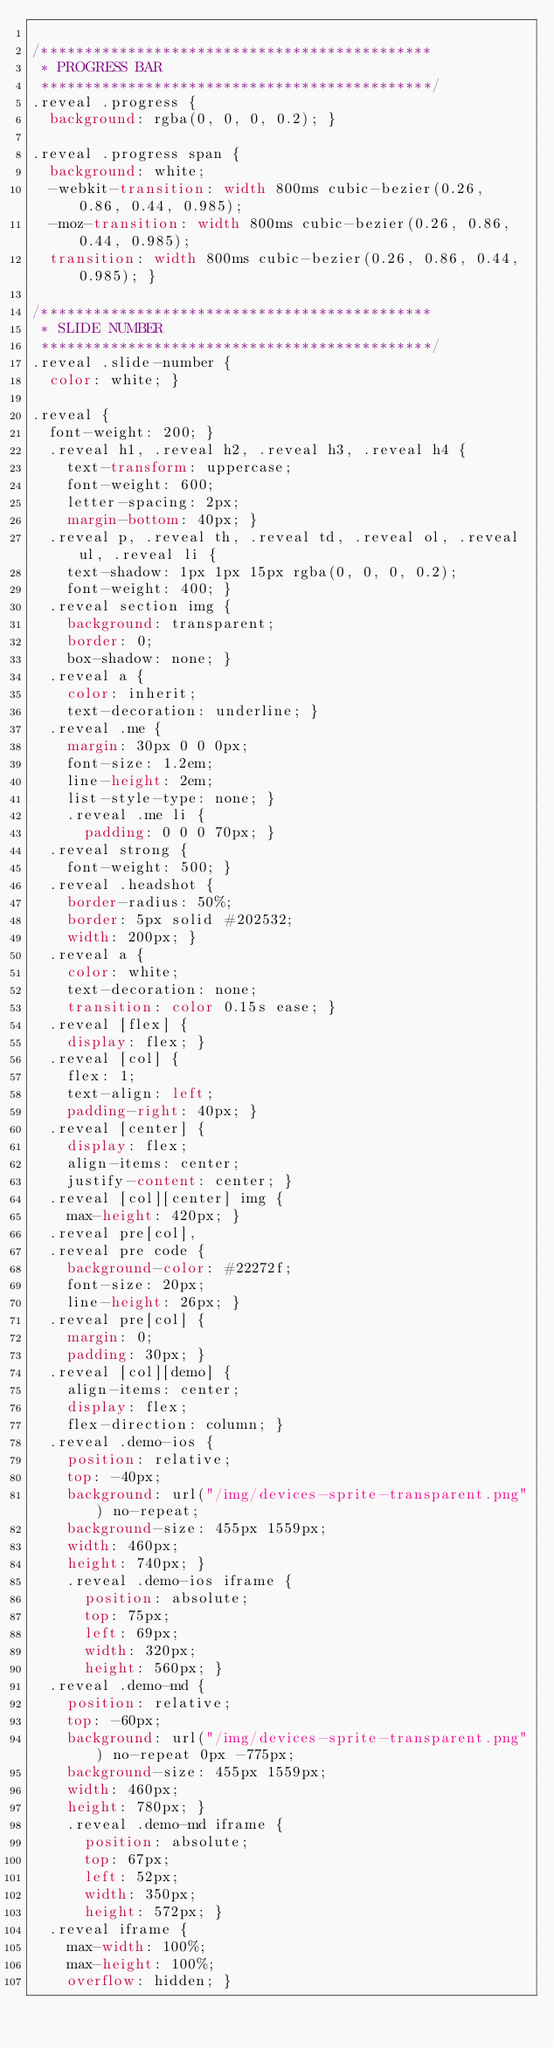<code> <loc_0><loc_0><loc_500><loc_500><_CSS_>
/*********************************************
 * PROGRESS BAR
 *********************************************/
.reveal .progress {
  background: rgba(0, 0, 0, 0.2); }

.reveal .progress span {
  background: white;
  -webkit-transition: width 800ms cubic-bezier(0.26, 0.86, 0.44, 0.985);
  -moz-transition: width 800ms cubic-bezier(0.26, 0.86, 0.44, 0.985);
  transition: width 800ms cubic-bezier(0.26, 0.86, 0.44, 0.985); }

/*********************************************
 * SLIDE NUMBER
 *********************************************/
.reveal .slide-number {
  color: white; }

.reveal {
  font-weight: 200; }
  .reveal h1, .reveal h2, .reveal h3, .reveal h4 {
    text-transform: uppercase;
    font-weight: 600;
    letter-spacing: 2px;
    margin-bottom: 40px; }
  .reveal p, .reveal th, .reveal td, .reveal ol, .reveal ul, .reveal li {
    text-shadow: 1px 1px 15px rgba(0, 0, 0, 0.2);
    font-weight: 400; }
  .reveal section img {
    background: transparent;
    border: 0;
    box-shadow: none; }
  .reveal a {
    color: inherit;
    text-decoration: underline; }
  .reveal .me {
    margin: 30px 0 0 0px;
    font-size: 1.2em;
    line-height: 2em;
    list-style-type: none; }
    .reveal .me li {
      padding: 0 0 0 70px; }
  .reveal strong {
    font-weight: 500; }
  .reveal .headshot {
    border-radius: 50%;
    border: 5px solid #202532;
    width: 200px; }
  .reveal a {
    color: white;
    text-decoration: none;
    transition: color 0.15s ease; }
  .reveal [flex] {
    display: flex; }
  .reveal [col] {
    flex: 1;
    text-align: left;
    padding-right: 40px; }
  .reveal [center] {
    display: flex;
    align-items: center;
    justify-content: center; }
  .reveal [col][center] img {
    max-height: 420px; }
  .reveal pre[col],
  .reveal pre code {
    background-color: #22272f;
    font-size: 20px;
    line-height: 26px; }
  .reveal pre[col] {
    margin: 0;
    padding: 30px; }
  .reveal [col][demo] {
    align-items: center;
    display: flex;
    flex-direction: column; }
  .reveal .demo-ios {
    position: relative;
    top: -40px;
    background: url("/img/devices-sprite-transparent.png") no-repeat;
    background-size: 455px 1559px;
    width: 460px;
    height: 740px; }
    .reveal .demo-ios iframe {
      position: absolute;
      top: 75px;
      left: 69px;
      width: 320px;
      height: 560px; }
  .reveal .demo-md {
    position: relative;
    top: -60px;
    background: url("/img/devices-sprite-transparent.png") no-repeat 0px -775px;
    background-size: 455px 1559px;
    width: 460px;
    height: 780px; }
    .reveal .demo-md iframe {
      position: absolute;
      top: 67px;
      left: 52px;
      width: 350px;
      height: 572px; }
  .reveal iframe {
    max-width: 100%;
    max-height: 100%;
    overflow: hidden; }
</code> 